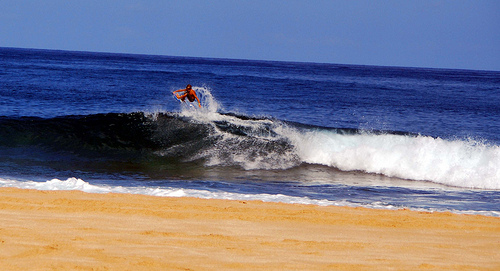Please provide the bounding box coordinate of the region this sentence describes: Top of wave is white. The crest of the wave, shrouded in frothy white foam, dynamically stands out at these coordinates: [0.72, 0.45, 0.95, 0.55], symbolizing the ocean's untamed energy. 